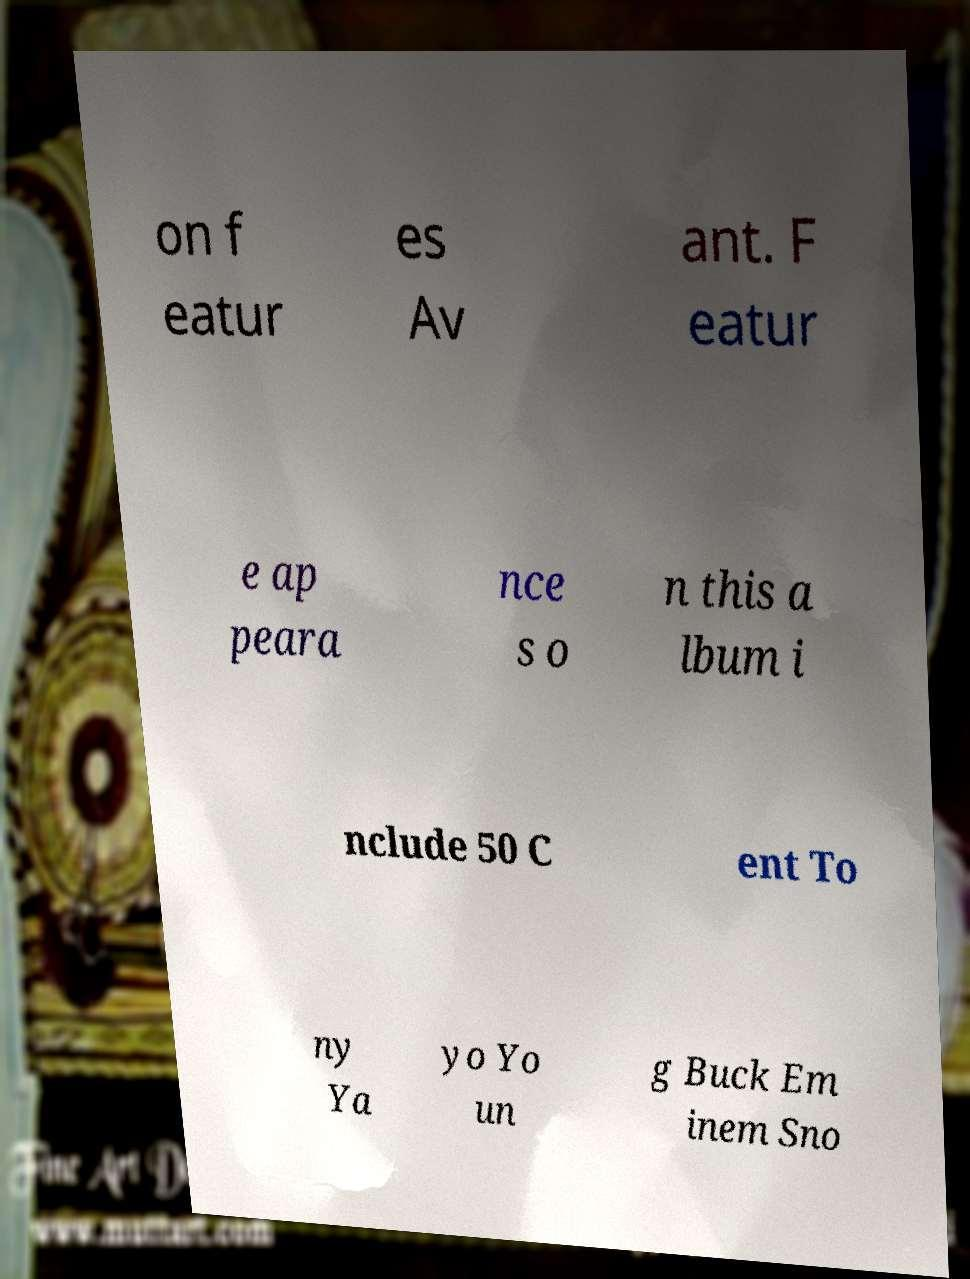Can you read and provide the text displayed in the image?This photo seems to have some interesting text. Can you extract and type it out for me? on f eatur es Av ant. F eatur e ap peara nce s o n this a lbum i nclude 50 C ent To ny Ya yo Yo un g Buck Em inem Sno 